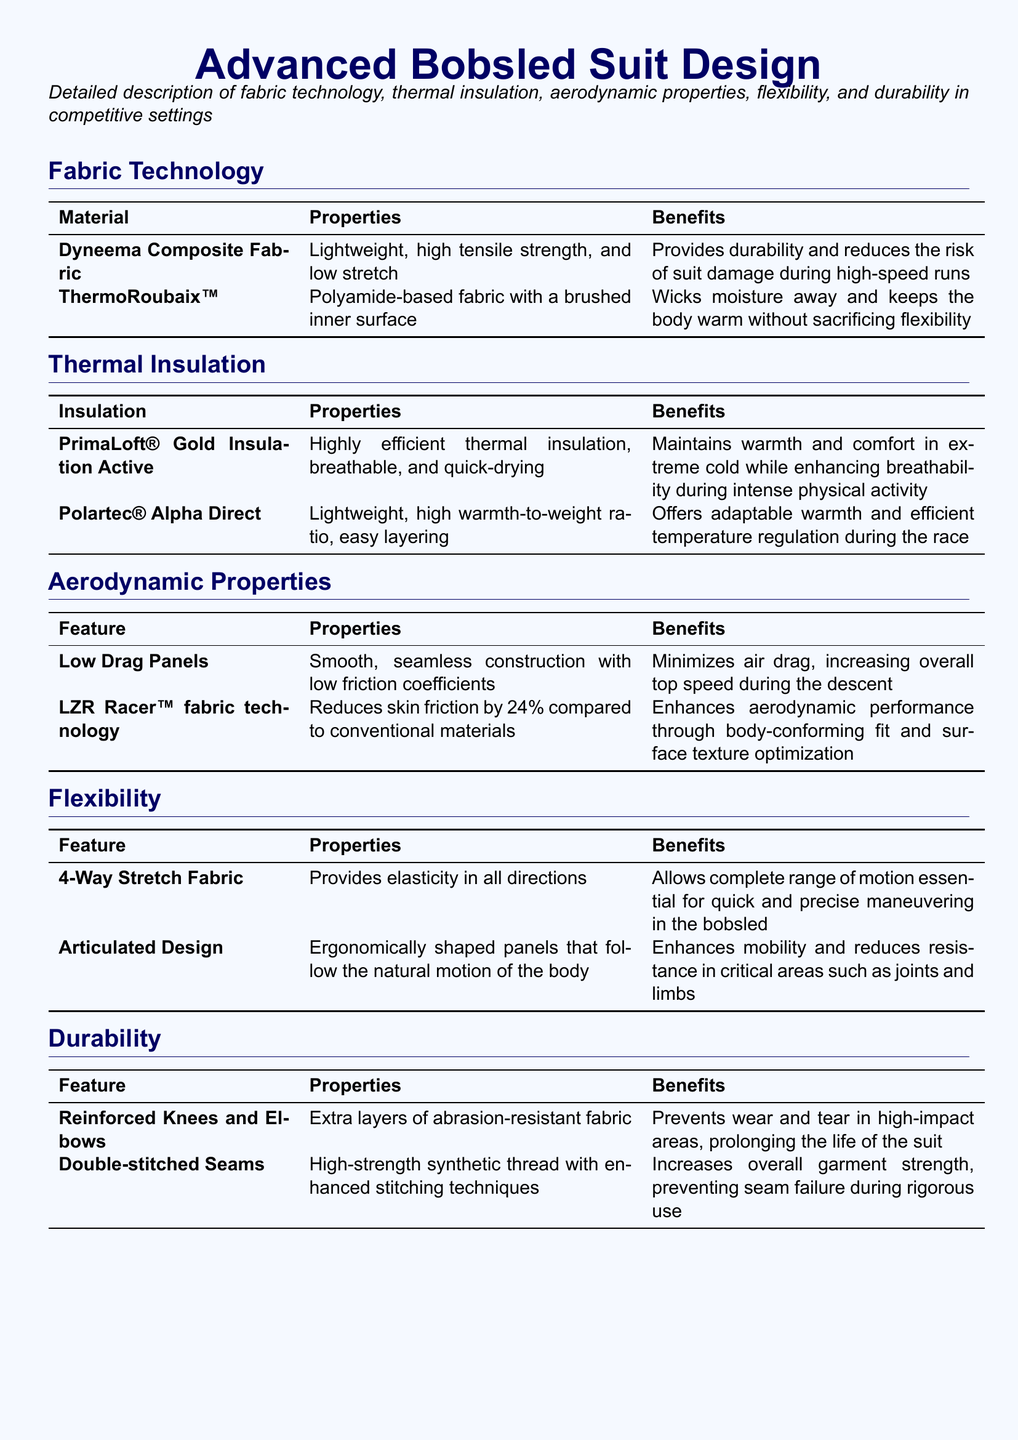What material is used for the low drag panels? The low drag panels feature a smooth, seamless construction, but the specific material is not specified.
Answer: Not specified What insulation is used in extreme cold? The document mentions PrimaLoft® Gold Insulation Active as maintaining warmth in extreme cold.
Answer: PrimaLoft® Gold Insulation Active How much does LZR Racer™ fabric technology reduce skin friction? The document states that LZR Racer™ fabric technology reduces skin friction by 24%.
Answer: 24% What feature allows for a complete range of motion? The feature that provides elasticity in all directions is the 4-Way Stretch Fabric.
Answer: 4-Way Stretch Fabric Which fabric technology wicks moisture away? The ThermoRoubaix™ fabric is noted for wicking moisture away.
Answer: ThermoRoubaix™ What benefit do reinforced knees and elbows provide? Reinforced knees and elbows prevent wear and tear in high-impact areas.
Answer: Prevents wear and tear Which design aspect enhances mobility in the bobsled suit? The articulated design enhances mobility and reduces resistance in critical areas.
Answer: Articulated Design What technology is known for quick-drying properties? PrimaLoft® Gold Insulation Active is highlighted for being quick-drying.
Answer: PrimaLoft® Gold Insulation Active What ensures the strength of seams in the suit? Double-stitched seams increase overall garment strength.
Answer: Double-stitched Seams 